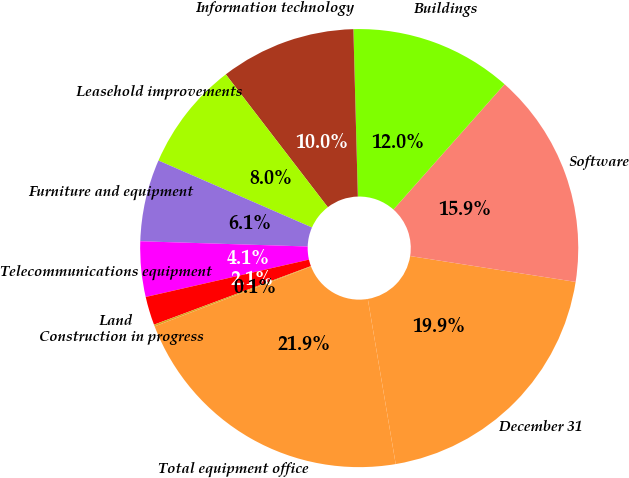Convert chart. <chart><loc_0><loc_0><loc_500><loc_500><pie_chart><fcel>December 31<fcel>Software<fcel>Buildings<fcel>Information technology<fcel>Leasehold improvements<fcel>Furniture and equipment<fcel>Telecommunications equipment<fcel>Land<fcel>Construction in progress<fcel>Total equipment office<nl><fcel>19.87%<fcel>15.92%<fcel>11.97%<fcel>10.0%<fcel>8.03%<fcel>6.05%<fcel>4.08%<fcel>2.1%<fcel>0.13%<fcel>21.85%<nl></chart> 